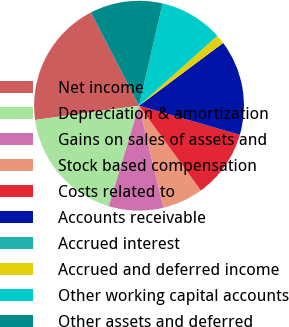Convert chart to OTSL. <chart><loc_0><loc_0><loc_500><loc_500><pie_chart><fcel>Net income<fcel>Depreciation & amortization<fcel>Gains on sales of assets and<fcel>Stock based compensation<fcel>Costs related to<fcel>Accounts receivable<fcel>Accrued interest<fcel>Accrued and deferred income<fcel>Other working capital accounts<fcel>Other assets and deferred<nl><fcel>19.58%<fcel>18.18%<fcel>8.39%<fcel>6.29%<fcel>10.49%<fcel>14.68%<fcel>0.0%<fcel>1.4%<fcel>9.79%<fcel>11.19%<nl></chart> 